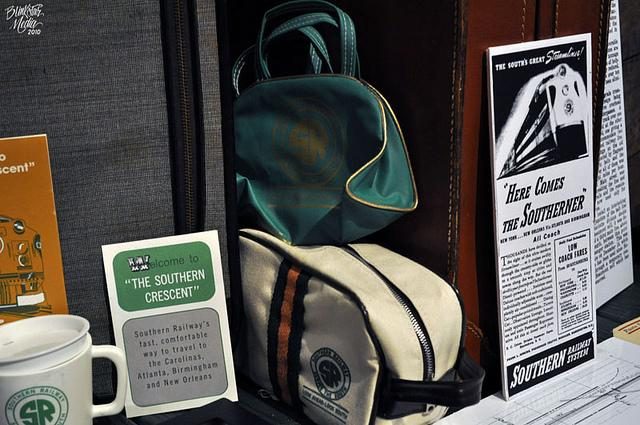What mode of transportation is The Southerner?

Choices:
A) truck
B) train
C) bus
D) van train 